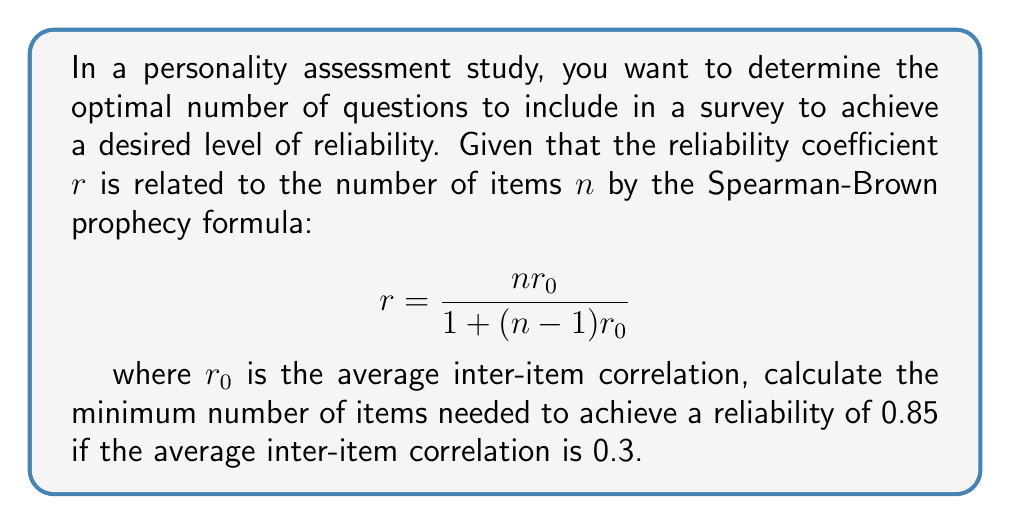Help me with this question. To solve this problem, we'll use the Spearman-Brown prophecy formula and follow these steps:

1. Identify the given information:
   - Desired reliability: $r = 0.85$
   - Average inter-item correlation: $r_0 = 0.3$

2. Substitute the values into the Spearman-Brown formula:
   $$0.85 = \frac{n(0.3)}{1+(n-1)(0.3)}$$

3. Multiply both sides by the denominator:
   $$0.85[1+(n-1)(0.3)] = n(0.3)$$

4. Expand the left side:
   $$0.85 + 0.85(n-1)(0.3) = 0.3n$$

5. Simplify:
   $$0.85 + 0.255n - 0.255 = 0.3n$$

6. Combine like terms:
   $$0.595 = 0.045n$$

7. Solve for n:
   $$n = \frac{0.595}{0.045} \approx 13.22$$

8. Since n must be a whole number, round up to the nearest integer:
   $$n = 14$$

Therefore, a minimum of 14 items are needed to achieve a reliability of 0.85.
Answer: 14 items 